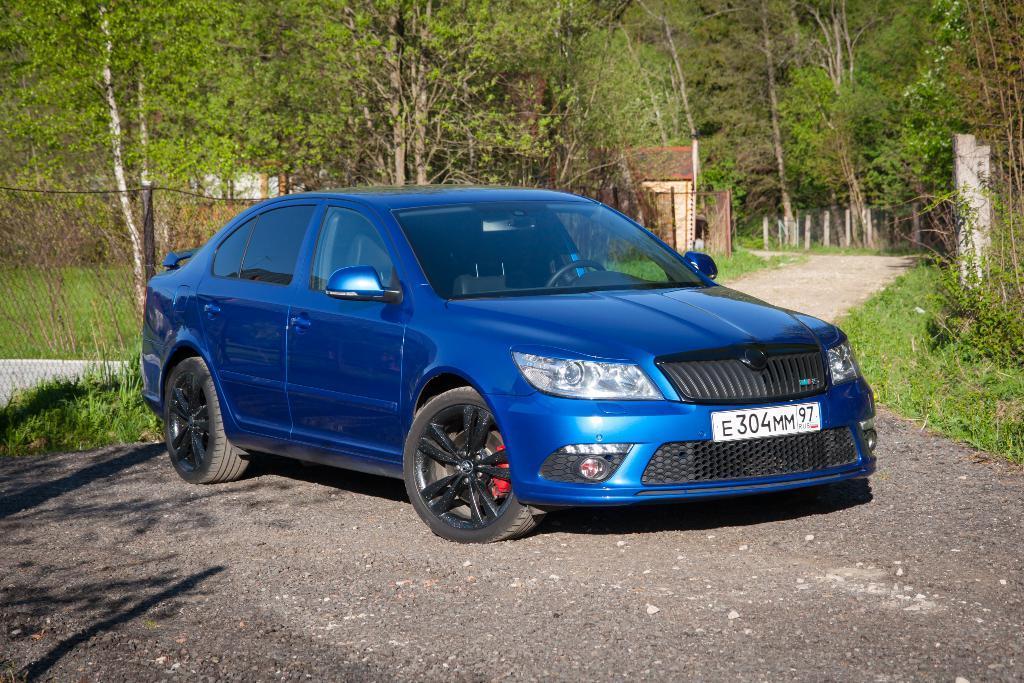How would you summarize this image in a sentence or two? This is the car, which is blue in color. This is a number plate, headlights, bumper, side mirrors, car doors, which are attached to the car. This looks like a fence. Here is the grass. This looks like a house. These are the trees. 